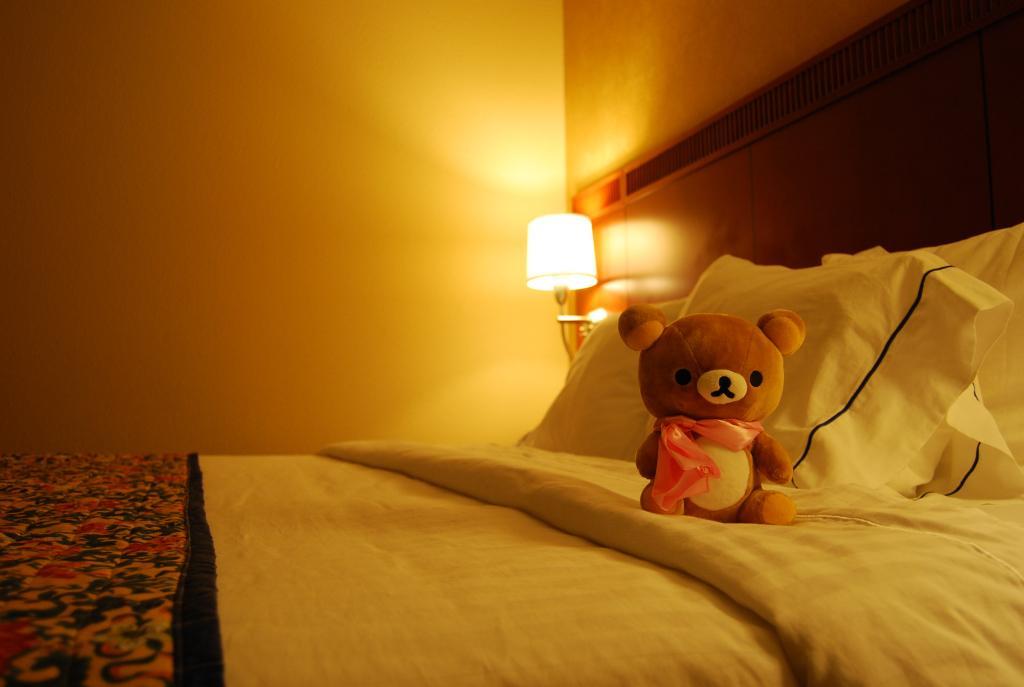Describe this image in one or two sentences. This is a picture inside the room. There is a bed and there is a toy on the bed and at the back there is a lamp. 